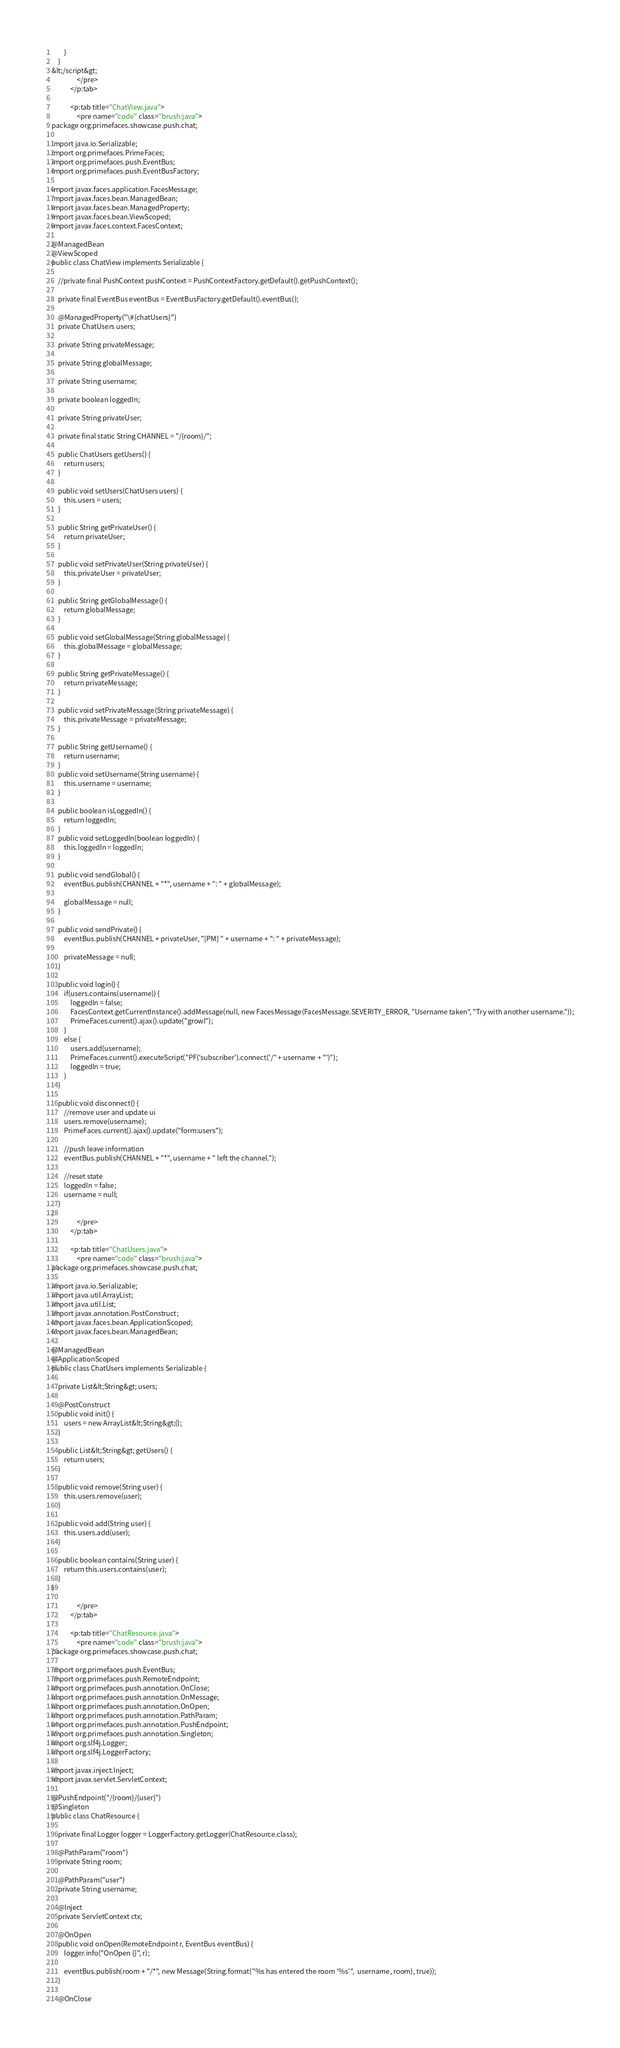Convert code to text. <code><loc_0><loc_0><loc_500><loc_500><_HTML_>        }
    }
&lt;/script&gt;
                </pre>
            </p:tab>

            <p:tab title="ChatView.java">
                <pre name="code" class="brush:java">
package org.primefaces.showcase.push.chat;

import java.io.Serializable;
import org.primefaces.PrimeFaces;
import org.primefaces.push.EventBus;
import org.primefaces.push.EventBusFactory;

import javax.faces.application.FacesMessage;
import javax.faces.bean.ManagedBean;
import javax.faces.bean.ManagedProperty;
import javax.faces.bean.ViewScoped;
import javax.faces.context.FacesContext;

@ManagedBean
@ViewScoped
public class ChatView implements Serializable {
    
    //private final PushContext pushContext = PushContextFactory.getDefault().getPushContext();

    private final EventBus eventBus = EventBusFactory.getDefault().eventBus();

    @ManagedProperty("\#{chatUsers}")
    private ChatUsers users;

	private String privateMessage;
    
    private String globalMessage;
	
	private String username;
	
	private boolean loggedIn;
    
    private String privateUser;
    
    private final static String CHANNEL = "/{room}/";

    public ChatUsers getUsers() {
        return users;
    }

    public void setUsers(ChatUsers users) {
        this.users = users;
    }
    
    public String getPrivateUser() {
        return privateUser;
    }

    public void setPrivateUser(String privateUser) {
        this.privateUser = privateUser;
    }

    public String getGlobalMessage() {
        return globalMessage;
    }

    public void setGlobalMessage(String globalMessage) {
        this.globalMessage = globalMessage;
    }

    public String getPrivateMessage() {
        return privateMessage;
    }

    public void setPrivateMessage(String privateMessage) {
        this.privateMessage = privateMessage;
    }
    
	public String getUsername() {
		return username;
	}
	public void setUsername(String username) {
		this.username = username;
	}
	
	public boolean isLoggedIn() {
		return loggedIn;
	}
	public void setLoggedIn(boolean loggedIn) {
		this.loggedIn = loggedIn;
	}

	public void sendGlobal() {
        eventBus.publish(CHANNEL + "*", username + ": " + globalMessage);
		
		globalMessage = null;
	}
    
    public void sendPrivate() {
        eventBus.publish(CHANNEL + privateUser, "[PM] " + username + ": " + privateMessage);
        
        privateMessage = null;
    }
	
	public void login() {
		if(users.contains(username)) {
            loggedIn = false;
            FacesContext.getCurrentInstance().addMessage(null, new FacesMessage(FacesMessage.SEVERITY_ERROR, "Username taken", "Try with another username."));
            PrimeFaces.current().ajax().update("growl");
        }
        else {
            users.add(username);
            PrimeFaces.current().executeScript("PF('subscriber').connect('/" + username + "')");
            loggedIn = true;
        }
	}
    
    public void disconnect() {
        //remove user and update ui
        users.remove(username);
        PrimeFaces.current().ajax().update("form:users");
        
        //push leave information
        eventBus.publish(CHANNEL + "*", username + " left the channel.");
        
        //reset state
        loggedIn = false;
        username = null;
    }
}
                </pre>
            </p:tab>
            
            <p:tab title="ChatUsers.java">
                <pre name="code" class="brush:java">
package org.primefaces.showcase.push.chat;

import java.io.Serializable;
import java.util.ArrayList;
import java.util.List;
import javax.annotation.PostConstruct;
import javax.faces.bean.ApplicationScoped;
import javax.faces.bean.ManagedBean;

@ManagedBean
@ApplicationScoped
public class ChatUsers implements Serializable {
    
    private List&lt;String&gt; users;
    
    @PostConstruct
    public void init() {
        users = new ArrayList&lt;String&gt;();
    }

    public List&lt;String&gt; getUsers() {
        return users;
    }
    
    public void remove(String user) {
        this.users.remove(user);
    }
    
    public void add(String user) {
        this.users.add(user);
    }
        
    public boolean contains(String user) {
        return this.users.contains(user);
    }
}

                </pre>
            </p:tab>
            
            <p:tab title="ChatResource.java">
                <pre name="code" class="brush:java">
package org.primefaces.showcase.push.chat;

import org.primefaces.push.EventBus;
import org.primefaces.push.RemoteEndpoint;
import org.primefaces.push.annotation.OnClose;
import org.primefaces.push.annotation.OnMessage;
import org.primefaces.push.annotation.OnOpen;
import org.primefaces.push.annotation.PathParam;
import org.primefaces.push.annotation.PushEndpoint;
import org.primefaces.push.annotation.Singleton;
import org.slf4j.Logger;
import org.slf4j.LoggerFactory;

import javax.inject.Inject;
import javax.servlet.ServletContext;

@PushEndpoint("/{room}/{user}")
@Singleton
public class ChatResource {

    private final Logger logger = LoggerFactory.getLogger(ChatResource.class);

    @PathParam("room")
    private String room;

    @PathParam("user")
    private String username;

    @Inject
    private ServletContext ctx;

    @OnOpen
    public void onOpen(RemoteEndpoint r, EventBus eventBus) {
        logger.info("OnOpen {}", r);

        eventBus.publish(room + "/*", new Message(String.format("%s has entered the room '%s'",  username, room), true));
    }

    @OnClose</code> 